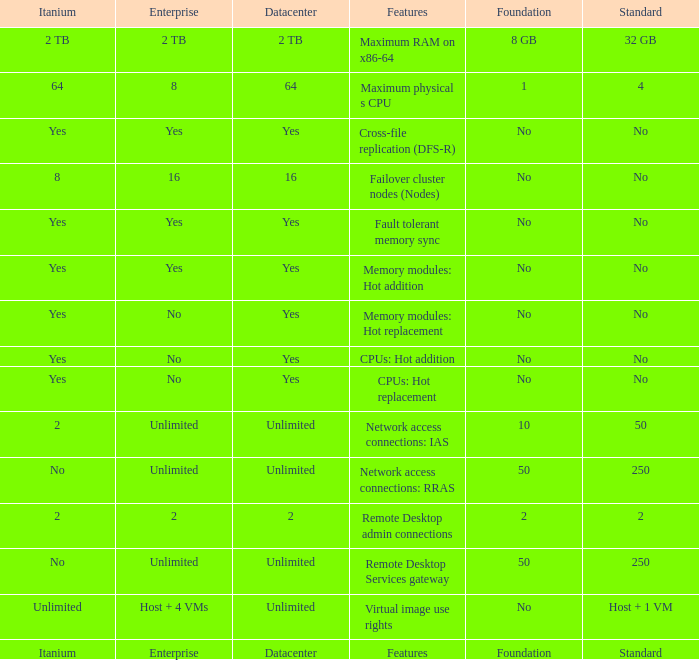What is the Datacenter for the Memory modules: hot addition Feature that has Yes listed for Itanium? Yes. 